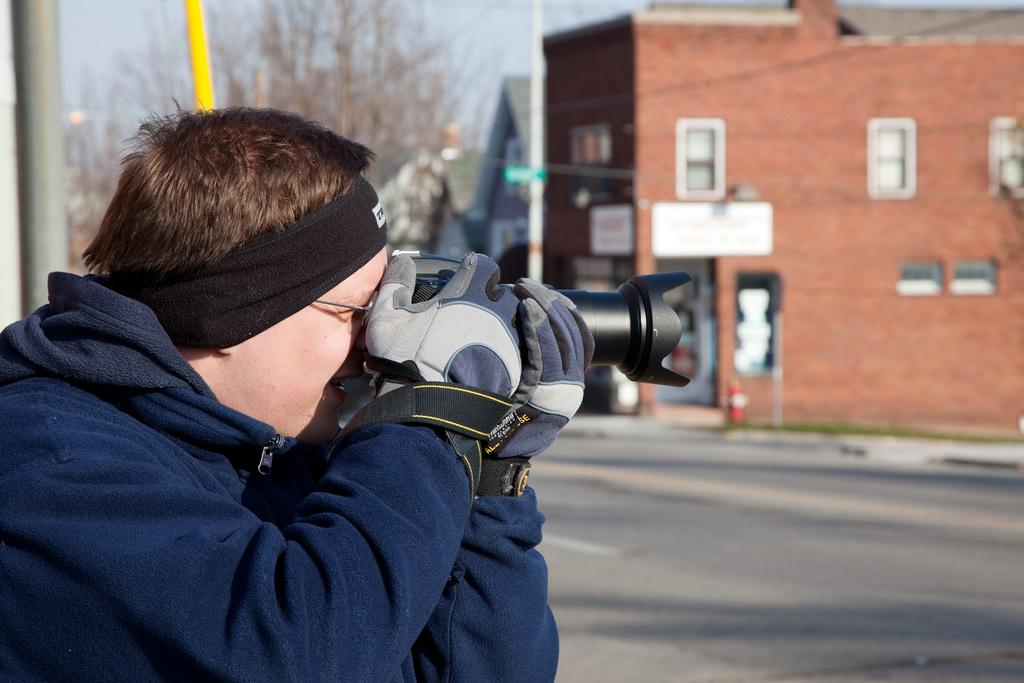What is the man on the left side of the image doing? The man is holding a camera in his hand, and he may be trying to take a picture. What can be seen in the background of the image? There is a building, a tree, and poles in the background of the image. What design can be seen on the swimsuit the man is wearing in the image? The man is not wearing a swimsuit in the image; he is wearing regular clothing. How does the man turn around in the image? The man does not turn around in the image; he is standing still while holding a camera. 